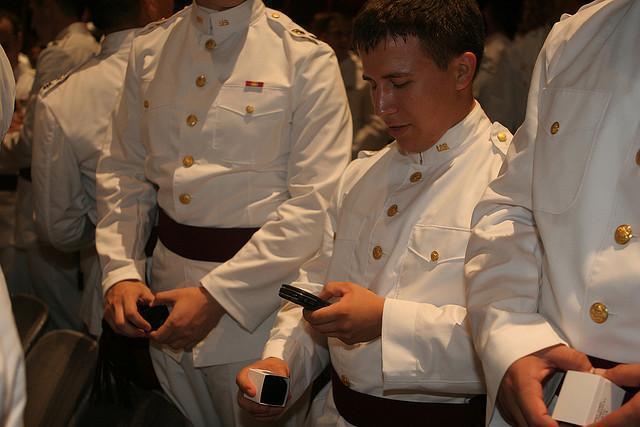What is the short man doing?
From the following four choices, select the correct answer to address the question.
Options: Texting, playing game, taking photo, online shopping. Taking photo. 